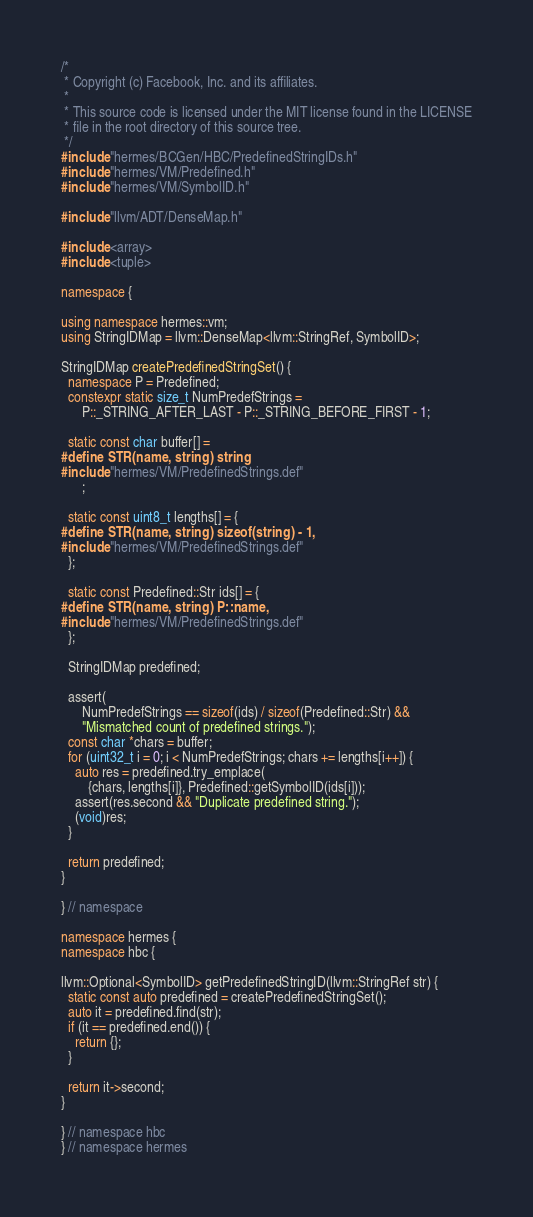Convert code to text. <code><loc_0><loc_0><loc_500><loc_500><_C++_>/*
 * Copyright (c) Facebook, Inc. and its affiliates.
 *
 * This source code is licensed under the MIT license found in the LICENSE
 * file in the root directory of this source tree.
 */
#include "hermes/BCGen/HBC/PredefinedStringIDs.h"
#include "hermes/VM/Predefined.h"
#include "hermes/VM/SymbolID.h"

#include "llvm/ADT/DenseMap.h"

#include <array>
#include <tuple>

namespace {

using namespace hermes::vm;
using StringIDMap = llvm::DenseMap<llvm::StringRef, SymbolID>;

StringIDMap createPredefinedStringSet() {
  namespace P = Predefined;
  constexpr static size_t NumPredefStrings =
      P::_STRING_AFTER_LAST - P::_STRING_BEFORE_FIRST - 1;

  static const char buffer[] =
#define STR(name, string) string
#include "hermes/VM/PredefinedStrings.def"
      ;

  static const uint8_t lengths[] = {
#define STR(name, string) sizeof(string) - 1,
#include "hermes/VM/PredefinedStrings.def"
  };

  static const Predefined::Str ids[] = {
#define STR(name, string) P::name,
#include "hermes/VM/PredefinedStrings.def"
  };

  StringIDMap predefined;

  assert(
      NumPredefStrings == sizeof(ids) / sizeof(Predefined::Str) &&
      "Mismatched count of predefined strings.");
  const char *chars = buffer;
  for (uint32_t i = 0; i < NumPredefStrings; chars += lengths[i++]) {
    auto res = predefined.try_emplace(
        {chars, lengths[i]}, Predefined::getSymbolID(ids[i]));
    assert(res.second && "Duplicate predefined string.");
    (void)res;
  }

  return predefined;
}

} // namespace

namespace hermes {
namespace hbc {

llvm::Optional<SymbolID> getPredefinedStringID(llvm::StringRef str) {
  static const auto predefined = createPredefinedStringSet();
  auto it = predefined.find(str);
  if (it == predefined.end()) {
    return {};
  }

  return it->second;
}

} // namespace hbc
} // namespace hermes
</code> 